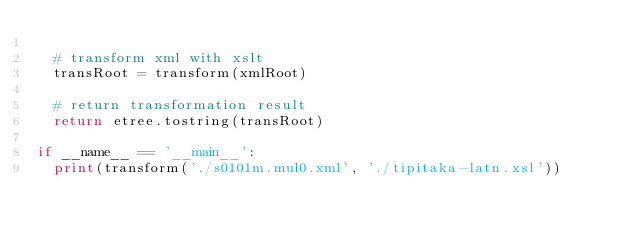<code> <loc_0><loc_0><loc_500><loc_500><_Python_>
  # transform xml with xslt
  transRoot = transform(xmlRoot)

  # return transformation result
  return etree.tostring(transRoot)

if __name__ == '__main__':
  print(transform('./s0101m.mul0.xml', './tipitaka-latn.xsl'))
</code> 